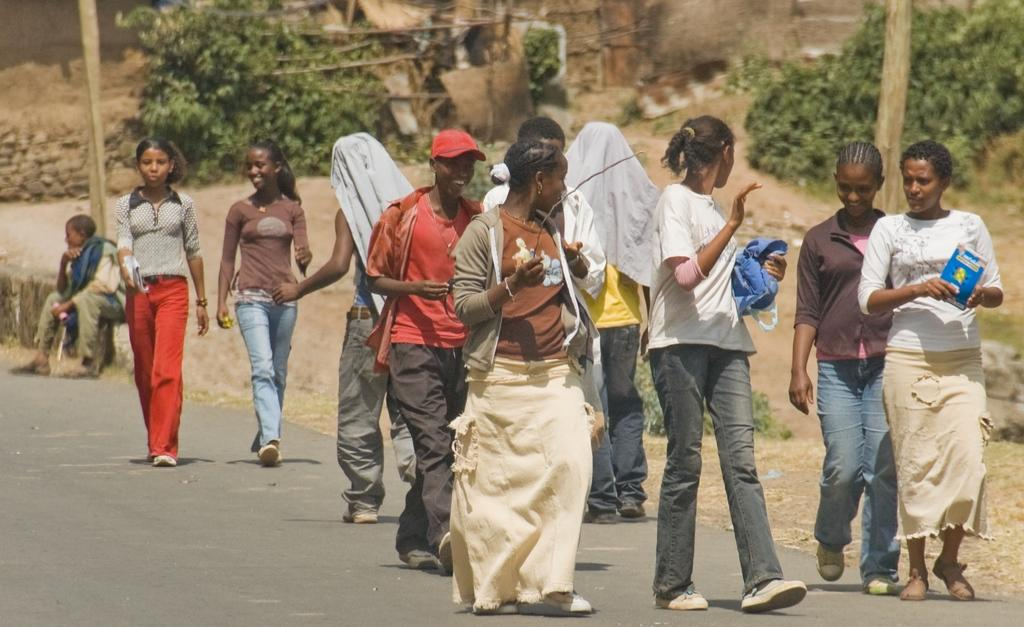What are the people in the image doing? The people in the image are walking on a road. Can you describe the man in the background of the image? There is a man sitting in the background of the image. What can be seen in the background besides the man? There are plants in the background of the image. How would you describe the appearance of the background? The background appears blurred. What type of lace can be seen on the man's clothing in the image? There is no lace visible on the man's clothing in the image. Can you hear the wren singing in the background of the image? There is no mention of a wren or any sound in the image, so it cannot be determined if a wren is singing. 